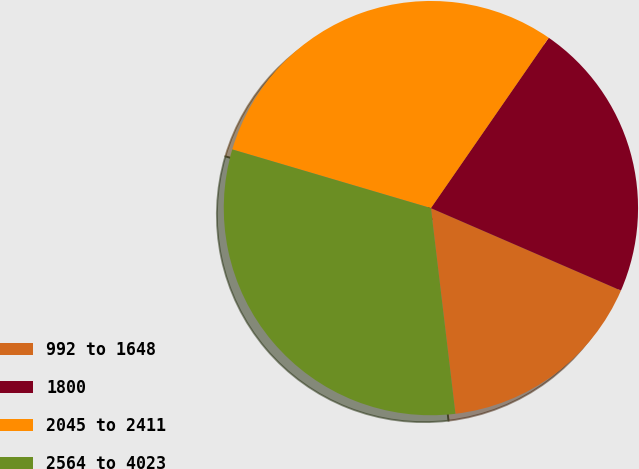Convert chart to OTSL. <chart><loc_0><loc_0><loc_500><loc_500><pie_chart><fcel>992 to 1648<fcel>1800<fcel>2045 to 2411<fcel>2564 to 4023<nl><fcel>16.6%<fcel>21.88%<fcel>30.06%<fcel>31.46%<nl></chart> 